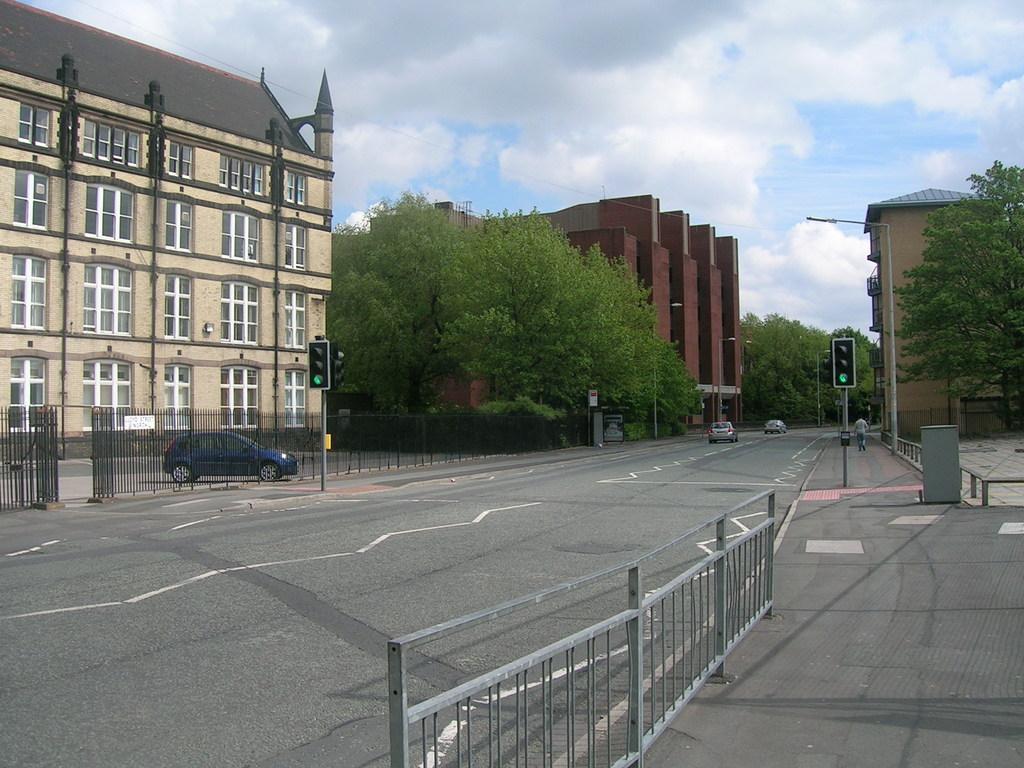Please provide a concise description of this image. In the left side it's a car is parked on the road, this is a building. In the middle there are trees, in the right side there are traffic signals. 